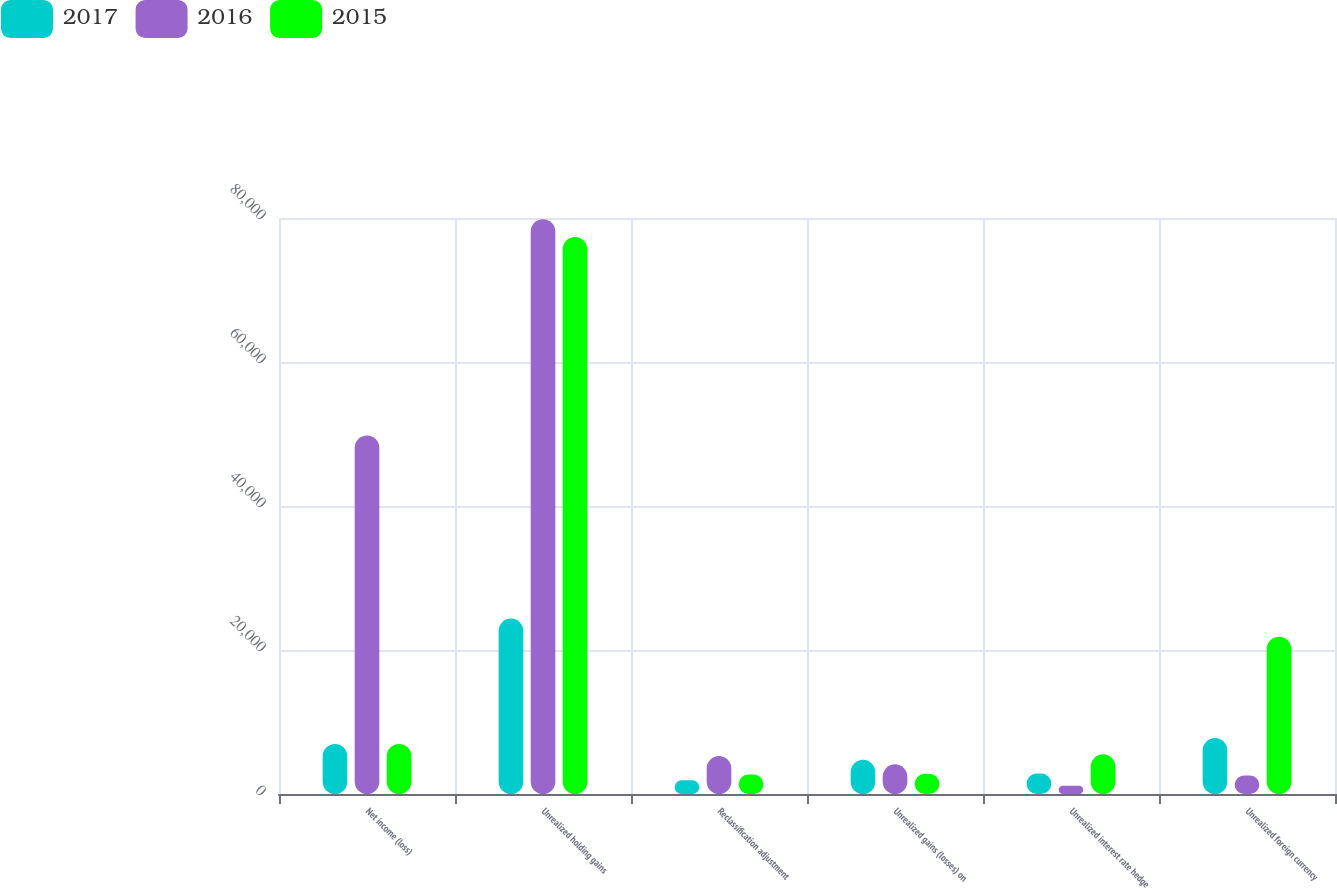Convert chart to OTSL. <chart><loc_0><loc_0><loc_500><loc_500><stacked_bar_chart><ecel><fcel>Net income (loss)<fcel>Unrealized holding gains<fcel>Reclassification adjustment<fcel>Unrealized gains (losses) on<fcel>Unrealized interest rate hedge<fcel>Unrealized foreign currency<nl><fcel>2017<fcel>6946<fcel>24360<fcel>1915<fcel>4752<fcel>2837<fcel>7774<nl><fcel>2016<fcel>49799<fcel>79833<fcel>5273<fcel>4123<fcel>1150<fcel>2579<nl><fcel>2015<fcel>6946<fcel>77370<fcel>2707<fcel>2809<fcel>5516<fcel>21844<nl></chart> 